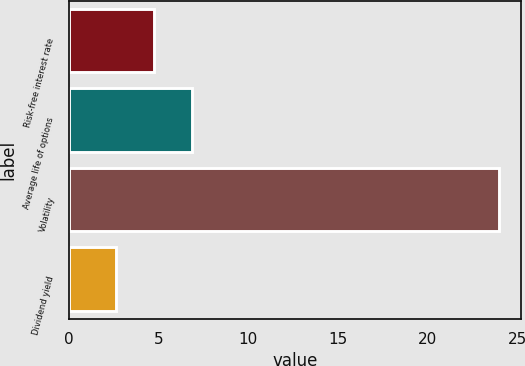Convert chart. <chart><loc_0><loc_0><loc_500><loc_500><bar_chart><fcel>Risk-free interest rate<fcel>Average life of options<fcel>Volatility<fcel>Dividend yield<nl><fcel>4.74<fcel>6.88<fcel>24<fcel>2.6<nl></chart> 